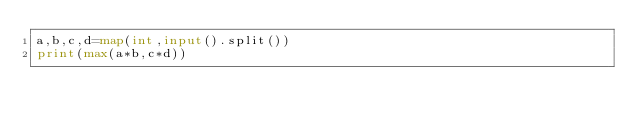Convert code to text. <code><loc_0><loc_0><loc_500><loc_500><_Python_>a,b,c,d=map(int,input().split())
print(max(a*b,c*d))
</code> 